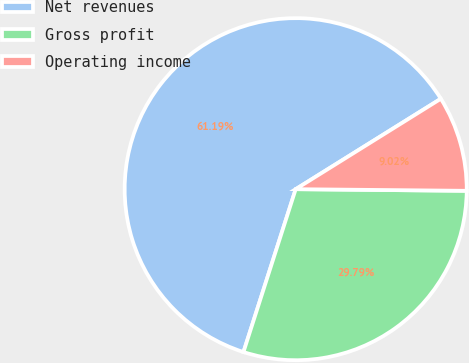<chart> <loc_0><loc_0><loc_500><loc_500><pie_chart><fcel>Net revenues<fcel>Gross profit<fcel>Operating income<nl><fcel>61.2%<fcel>29.79%<fcel>9.02%<nl></chart> 